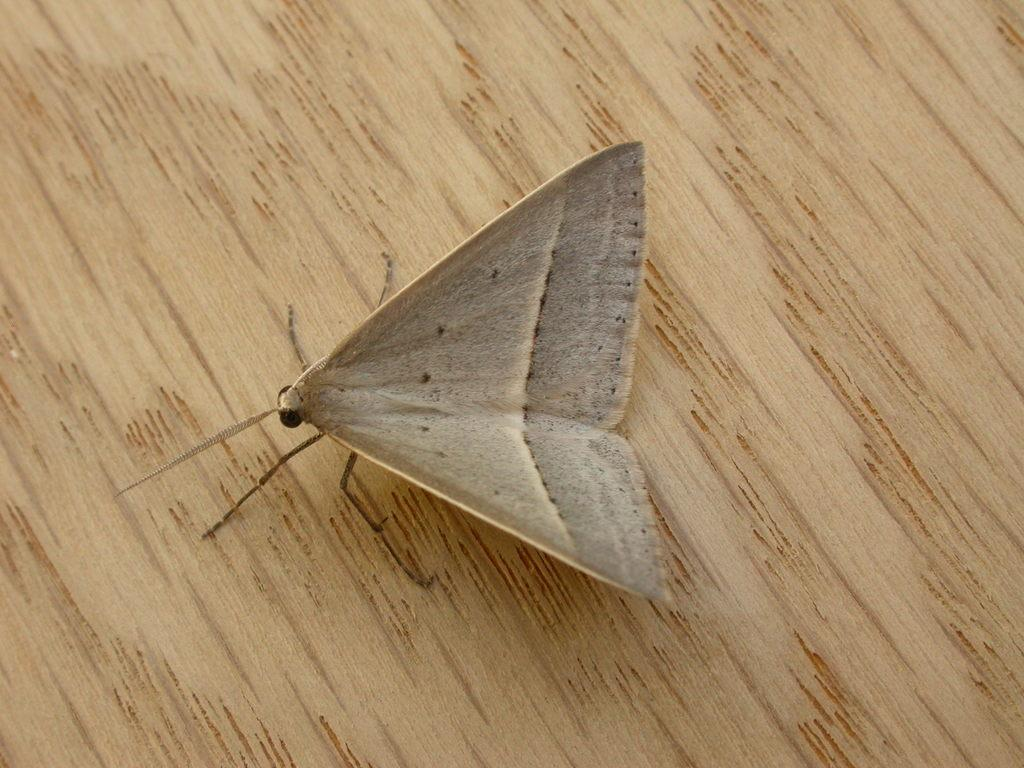What is the main subject of the image? There is a butterfly in the image. What is the butterfly sitting on? The butterfly is sitting on wood. What type of copper ring can be seen on the butterfly's leg in the image? There is no copper ring present on the butterfly's leg in the image. 